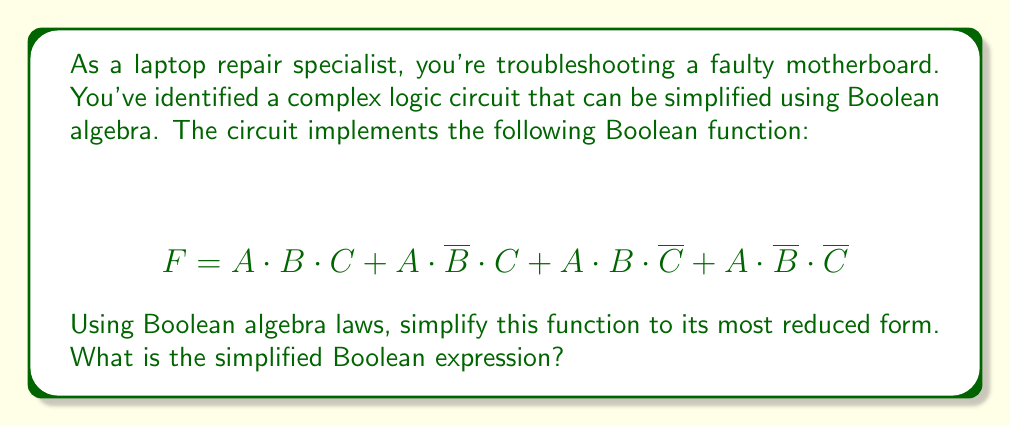What is the answer to this math problem? Let's simplify this Boolean function step by step using Boolean algebra laws:

1) First, we can factor out $A$ from all terms:
   $$ F = A \cdot (B \cdot C + \overline{B} \cdot C + B \cdot \overline{C} + \overline{B} \cdot \overline{C}) $$

2) Now, let's focus on the expression inside the parentheses. We can group the terms with $C$ and $\overline{C}$:
   $$ F = A \cdot ((B \cdot C + \overline{B} \cdot C) + (B \cdot \overline{C} + \overline{B} \cdot \overline{C})) $$

3) We can apply the distributive law to each group:
   $$ F = A \cdot ((B + \overline{B}) \cdot C + (B + \overline{B}) \cdot \overline{C}) $$

4) $(B + \overline{B})$ is always true (1) according to the law of the excluded middle:
   $$ F = A \cdot (1 \cdot C + 1 \cdot \overline{C}) $$

5) Simplify:
   $$ F = A \cdot (C + \overline{C}) $$

6) Again, $(C + \overline{C})$ is always true (1):
   $$ F = A \cdot 1 $$

7) Finally, simplify:
   $$ F = A $$

Therefore, the complex Boolean function simplifies to just $A$.
Answer: $F = A$ 